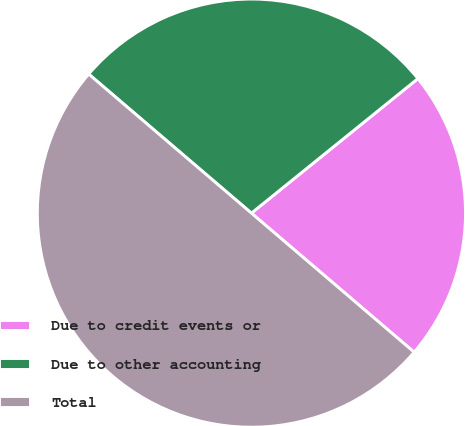<chart> <loc_0><loc_0><loc_500><loc_500><pie_chart><fcel>Due to credit events or<fcel>Due to other accounting<fcel>Total<nl><fcel>22.07%<fcel>27.93%<fcel>50.0%<nl></chart> 